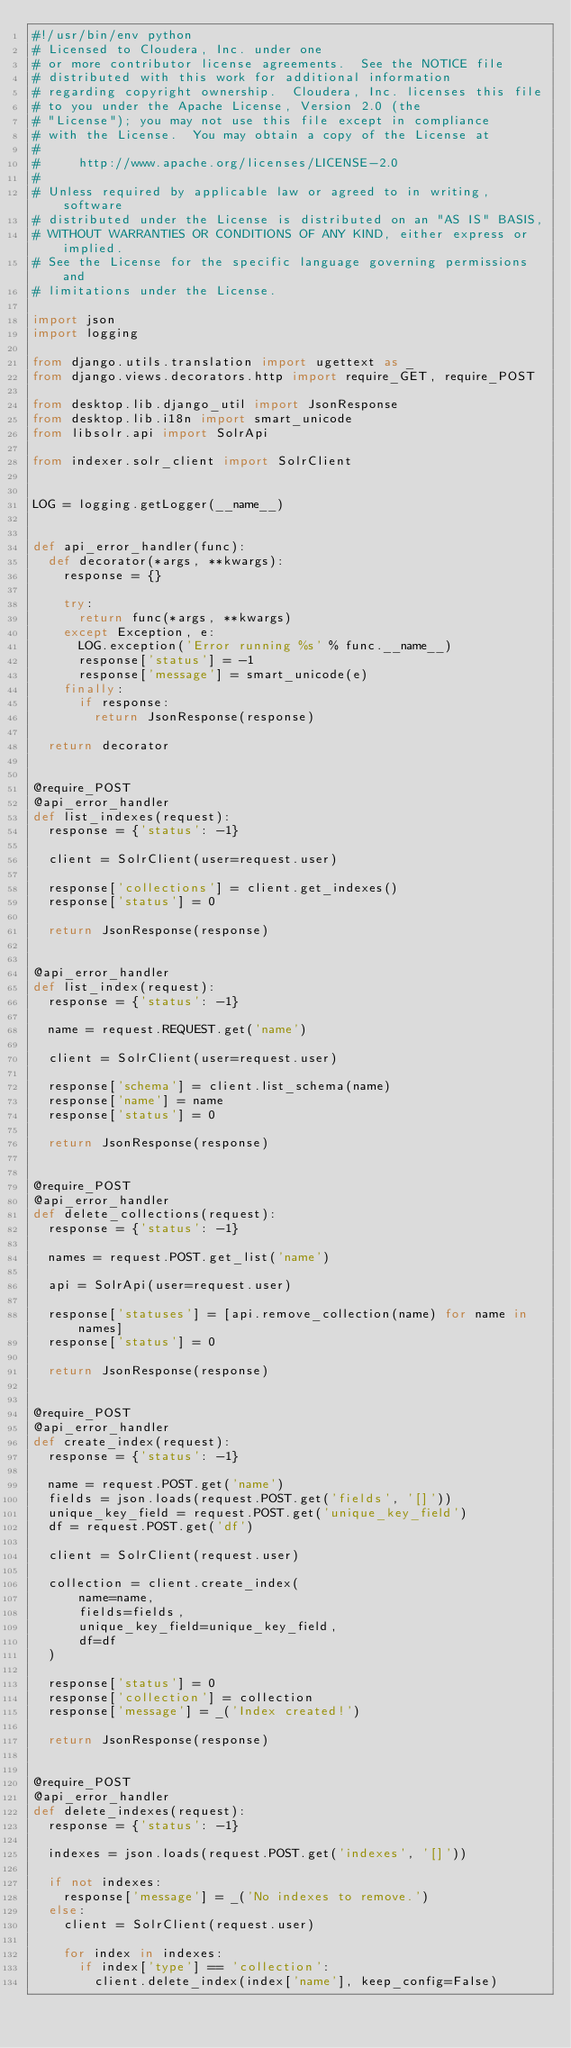Convert code to text. <code><loc_0><loc_0><loc_500><loc_500><_Python_>#!/usr/bin/env python
# Licensed to Cloudera, Inc. under one
# or more contributor license agreements.  See the NOTICE file
# distributed with this work for additional information
# regarding copyright ownership.  Cloudera, Inc. licenses this file
# to you under the Apache License, Version 2.0 (the
# "License"); you may not use this file except in compliance
# with the License.  You may obtain a copy of the License at
#
#     http://www.apache.org/licenses/LICENSE-2.0
#
# Unless required by applicable law or agreed to in writing, software
# distributed under the License is distributed on an "AS IS" BASIS,
# WITHOUT WARRANTIES OR CONDITIONS OF ANY KIND, either express or implied.
# See the License for the specific language governing permissions and
# limitations under the License.

import json
import logging

from django.utils.translation import ugettext as _
from django.views.decorators.http import require_GET, require_POST

from desktop.lib.django_util import JsonResponse
from desktop.lib.i18n import smart_unicode
from libsolr.api import SolrApi

from indexer.solr_client import SolrClient


LOG = logging.getLogger(__name__)


def api_error_handler(func):
  def decorator(*args, **kwargs):
    response = {}

    try:
      return func(*args, **kwargs)
    except Exception, e:
      LOG.exception('Error running %s' % func.__name__)
      response['status'] = -1
      response['message'] = smart_unicode(e)
    finally:
      if response:
        return JsonResponse(response)

  return decorator


@require_POST
@api_error_handler
def list_indexes(request):
  response = {'status': -1}

  client = SolrClient(user=request.user)

  response['collections'] = client.get_indexes()
  response['status'] = 0

  return JsonResponse(response)


@api_error_handler
def list_index(request):
  response = {'status': -1}

  name = request.REQUEST.get('name')

  client = SolrClient(user=request.user)

  response['schema'] = client.list_schema(name)
  response['name'] = name
  response['status'] = 0

  return JsonResponse(response)


@require_POST
@api_error_handler
def delete_collections(request):
  response = {'status': -1}

  names = request.POST.get_list('name')

  api = SolrApi(user=request.user)

  response['statuses'] = [api.remove_collection(name) for name in names]
  response['status'] = 0

  return JsonResponse(response)


@require_POST
@api_error_handler
def create_index(request):
  response = {'status': -1}

  name = request.POST.get('name')
  fields = json.loads(request.POST.get('fields', '[]'))
  unique_key_field = request.POST.get('unique_key_field')
  df = request.POST.get('df')

  client = SolrClient(request.user)

  collection = client.create_index(
      name=name,
      fields=fields,
      unique_key_field=unique_key_field,
      df=df
  )

  response['status'] = 0
  response['collection'] = collection
  response['message'] = _('Index created!')

  return JsonResponse(response)


@require_POST
@api_error_handler
def delete_indexes(request):
  response = {'status': -1}

  indexes = json.loads(request.POST.get('indexes', '[]'))

  if not indexes:
    response['message'] = _('No indexes to remove.')
  else:
    client = SolrClient(request.user)

    for index in indexes:
      if index['type'] == 'collection':
        client.delete_index(index['name'], keep_config=False)</code> 